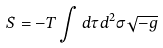Convert formula to latex. <formula><loc_0><loc_0><loc_500><loc_500>S = - T \int d \tau d ^ { 2 } \sigma \sqrt { - g }</formula> 